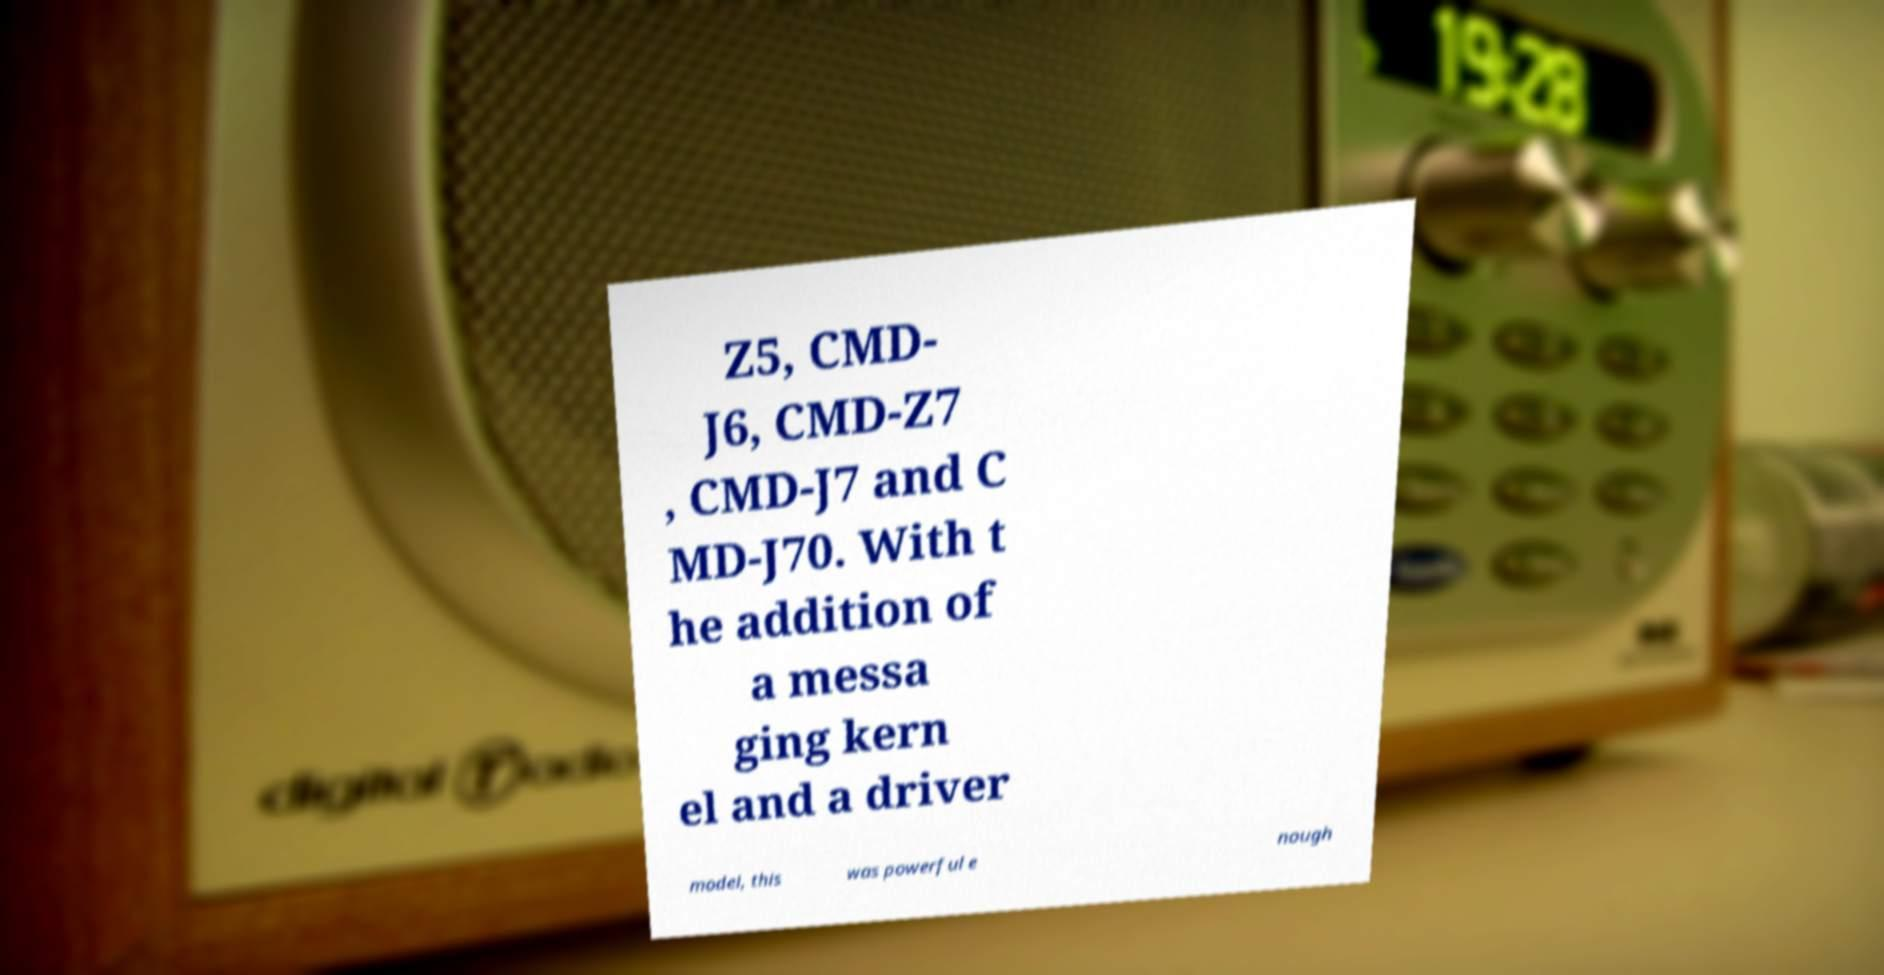Could you assist in decoding the text presented in this image and type it out clearly? Z5, CMD- J6, CMD-Z7 , CMD-J7 and C MD-J70. With t he addition of a messa ging kern el and a driver model, this was powerful e nough 